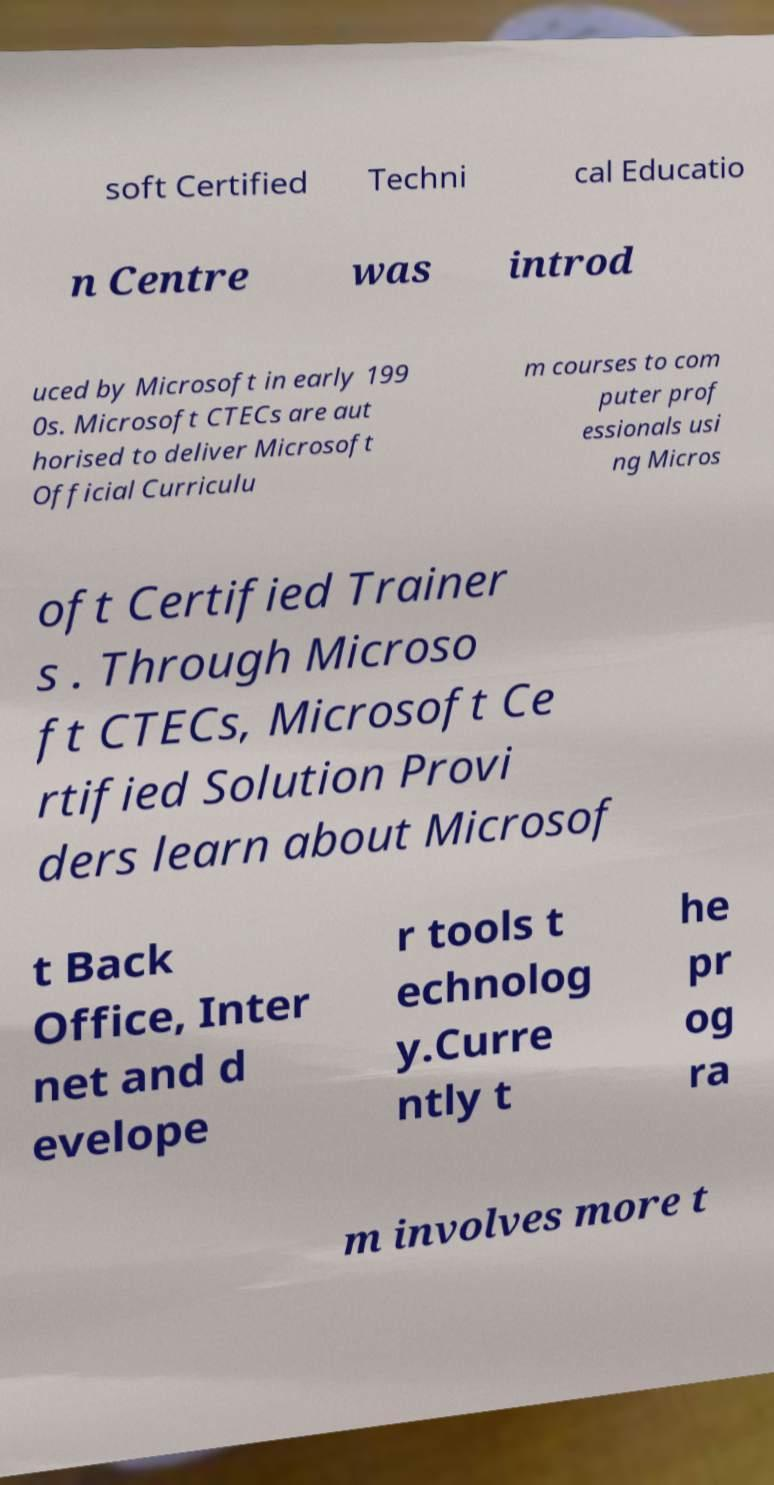Please read and relay the text visible in this image. What does it say? soft Certified Techni cal Educatio n Centre was introd uced by Microsoft in early 199 0s. Microsoft CTECs are aut horised to deliver Microsoft Official Curriculu m courses to com puter prof essionals usi ng Micros oft Certified Trainer s . Through Microso ft CTECs, Microsoft Ce rtified Solution Provi ders learn about Microsof t Back Office, Inter net and d evelope r tools t echnolog y.Curre ntly t he pr og ra m involves more t 